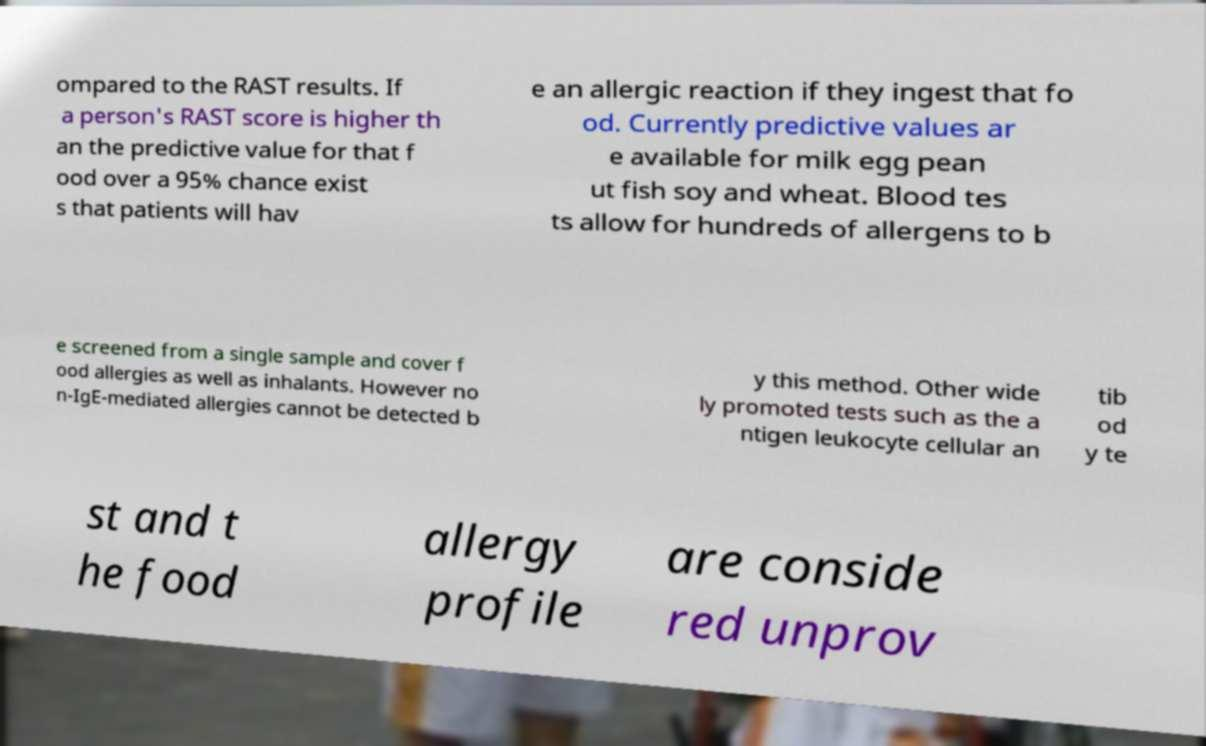Could you assist in decoding the text presented in this image and type it out clearly? ompared to the RAST results. If a person's RAST score is higher th an the predictive value for that f ood over a 95% chance exist s that patients will hav e an allergic reaction if they ingest that fo od. Currently predictive values ar e available for milk egg pean ut fish soy and wheat. Blood tes ts allow for hundreds of allergens to b e screened from a single sample and cover f ood allergies as well as inhalants. However no n-IgE-mediated allergies cannot be detected b y this method. Other wide ly promoted tests such as the a ntigen leukocyte cellular an tib od y te st and t he food allergy profile are conside red unprov 